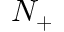<formula> <loc_0><loc_0><loc_500><loc_500>N _ { + }</formula> 